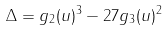Convert formula to latex. <formula><loc_0><loc_0><loc_500><loc_500>\Delta = g _ { 2 } ( u ) ^ { 3 } - 2 7 g _ { 3 } ( u ) ^ { 2 } \</formula> 